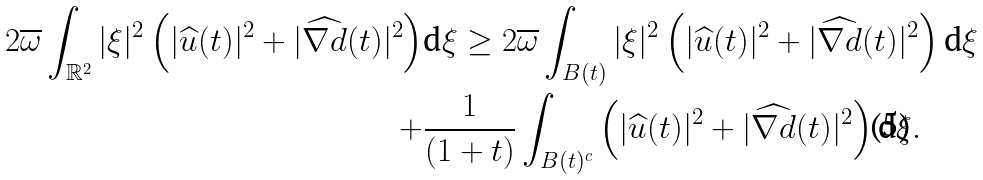Convert formula to latex. <formula><loc_0><loc_0><loc_500><loc_500>2 \overline { \omega } \int _ { \mathbb { R } ^ { 2 } } | \xi | ^ { 2 } \left ( | \widehat { u } ( t ) | ^ { 2 } + | \widehat { \nabla d } ( t ) | ^ { 2 } \right ) & \text {d} \xi \geq 2 \overline { \omega } \int _ { B ( t ) } | \xi | ^ { 2 } \left ( | \widehat { u } ( t ) | ^ { 2 } + | \widehat { \nabla d } ( t ) | ^ { 2 } \right ) \text {d} \xi \\ + & \frac { 1 } { ( 1 + t ) } \int _ { B ( t ) ^ { c } } \left ( | \widehat { u } ( t ) | ^ { 2 } + | \widehat { \nabla d } ( t ) | ^ { 2 } \right ) \text {d} \xi .</formula> 